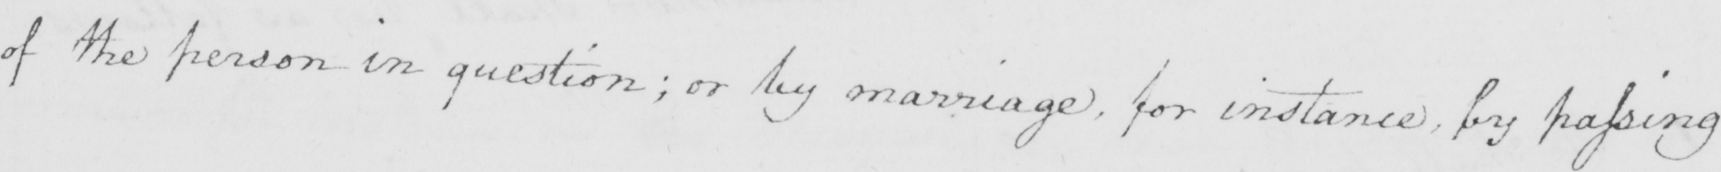Transcribe the text shown in this historical manuscript line. of the person in question ; or by marriage , for instance , by passing 